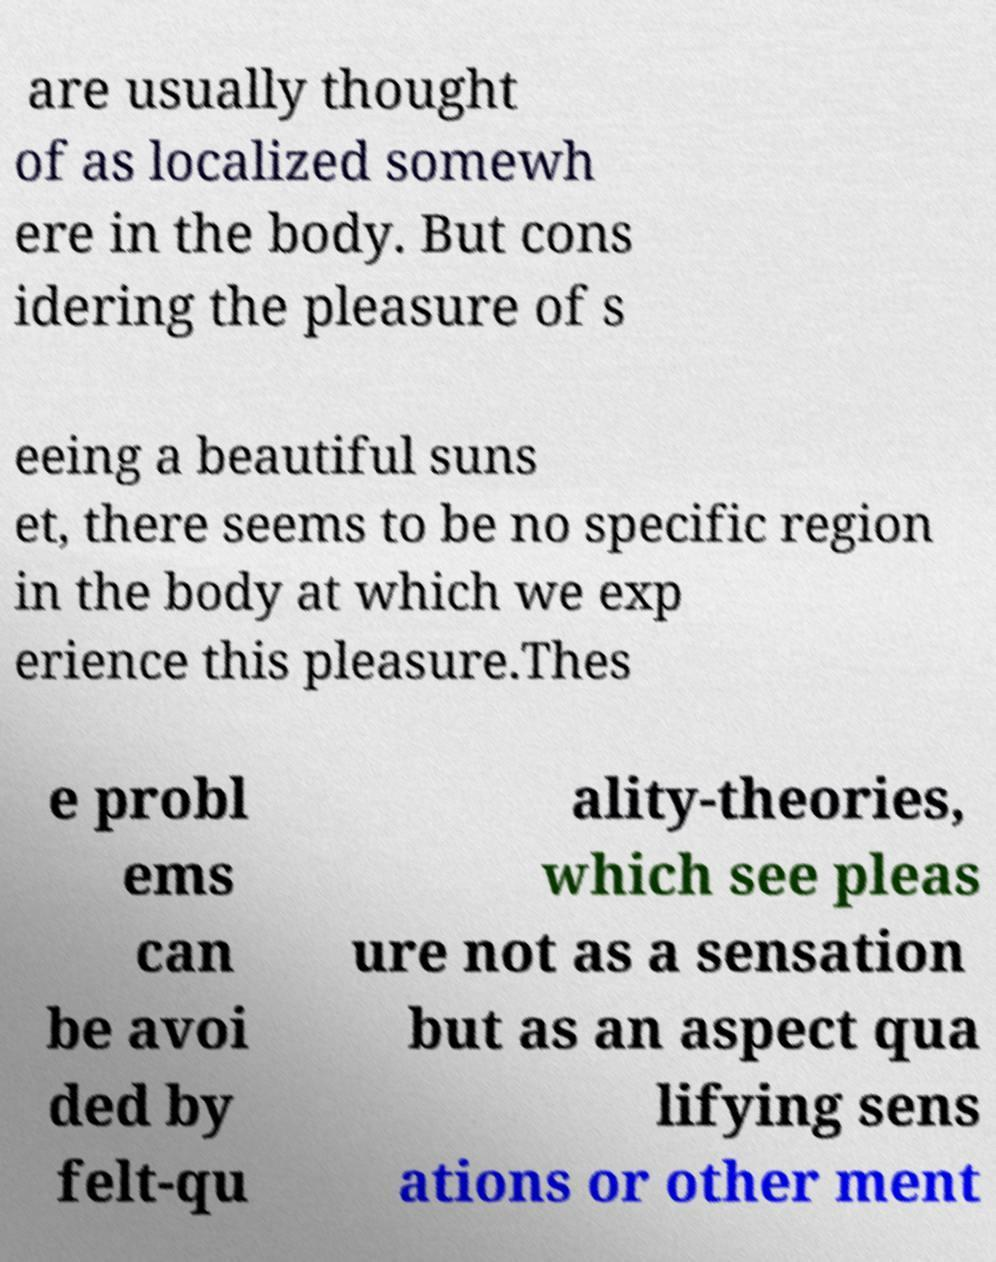I need the written content from this picture converted into text. Can you do that? are usually thought of as localized somewh ere in the body. But cons idering the pleasure of s eeing a beautiful suns et, there seems to be no specific region in the body at which we exp erience this pleasure.Thes e probl ems can be avoi ded by felt-qu ality-theories, which see pleas ure not as a sensation but as an aspect qua lifying sens ations or other ment 